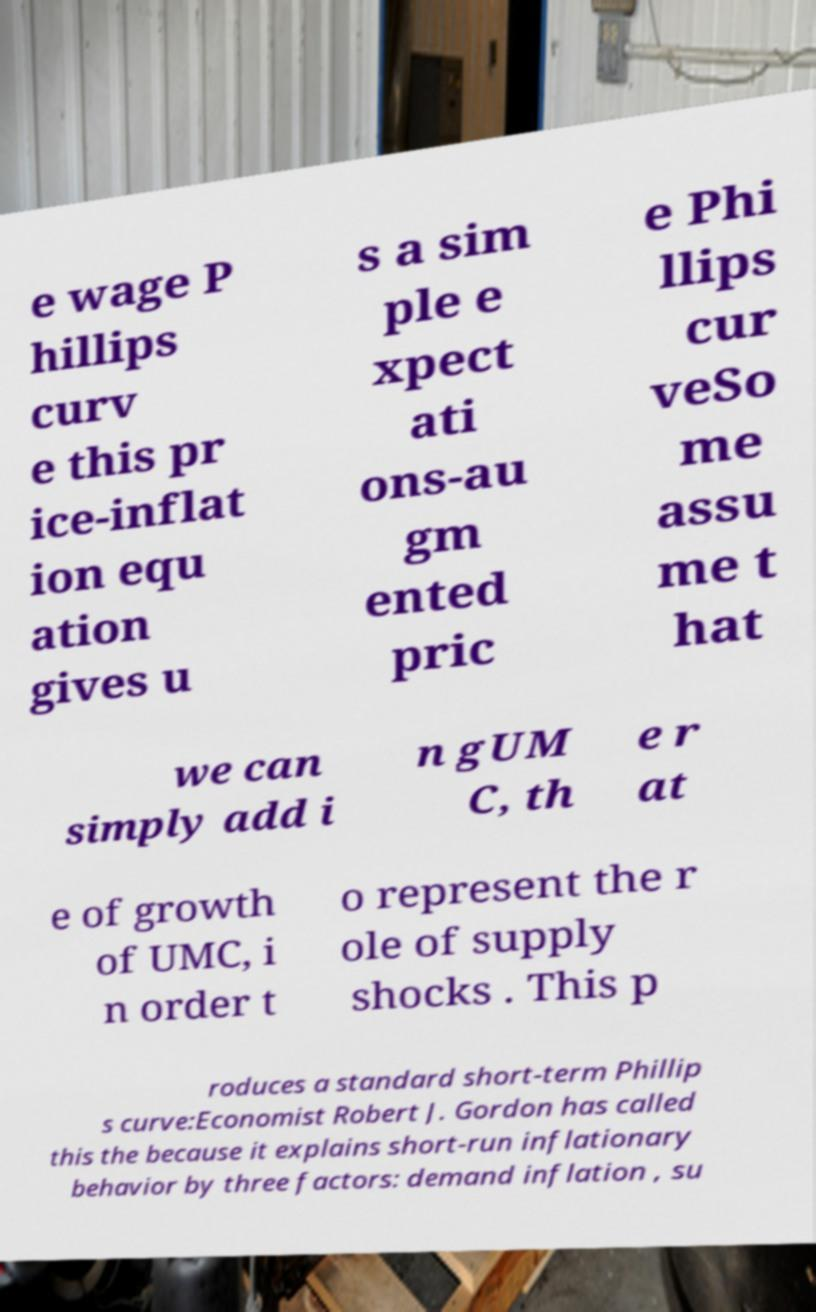Can you accurately transcribe the text from the provided image for me? e wage P hillips curv e this pr ice-inflat ion equ ation gives u s a sim ple e xpect ati ons-au gm ented pric e Phi llips cur veSo me assu me t hat we can simply add i n gUM C, th e r at e of growth of UMC, i n order t o represent the r ole of supply shocks . This p roduces a standard short-term Phillip s curve:Economist Robert J. Gordon has called this the because it explains short-run inflationary behavior by three factors: demand inflation , su 